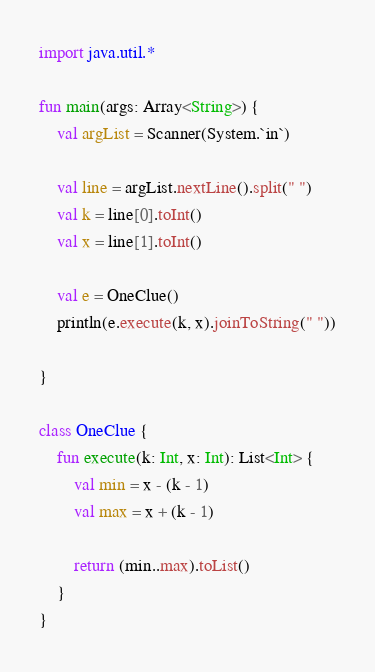Convert code to text. <code><loc_0><loc_0><loc_500><loc_500><_Kotlin_>import java.util.*

fun main(args: Array<String>) {
    val argList = Scanner(System.`in`)

    val line = argList.nextLine().split(" ")
    val k = line[0].toInt()
    val x = line[1].toInt()

    val e = OneClue()
    println(e.execute(k, x).joinToString(" "))

}

class OneClue {
    fun execute(k: Int, x: Int): List<Int> {
        val min = x - (k - 1)
        val max = x + (k - 1)

        return (min..max).toList()
    }
}</code> 